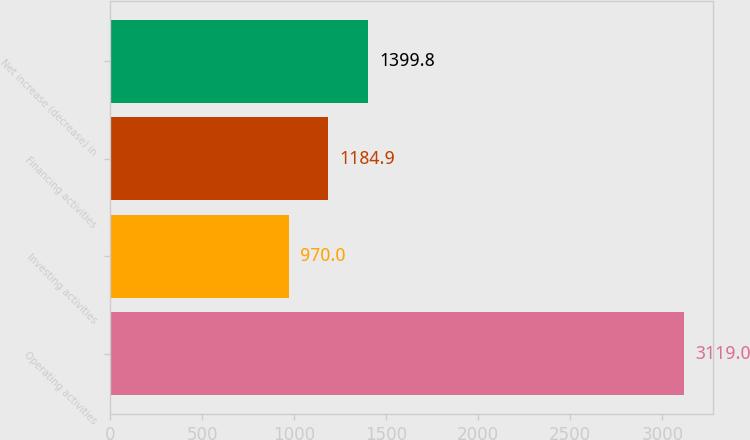Convert chart. <chart><loc_0><loc_0><loc_500><loc_500><bar_chart><fcel>Operating activities<fcel>Investing activities<fcel>Financing activities<fcel>Net increase (decrease) in<nl><fcel>3119<fcel>970<fcel>1184.9<fcel>1399.8<nl></chart> 